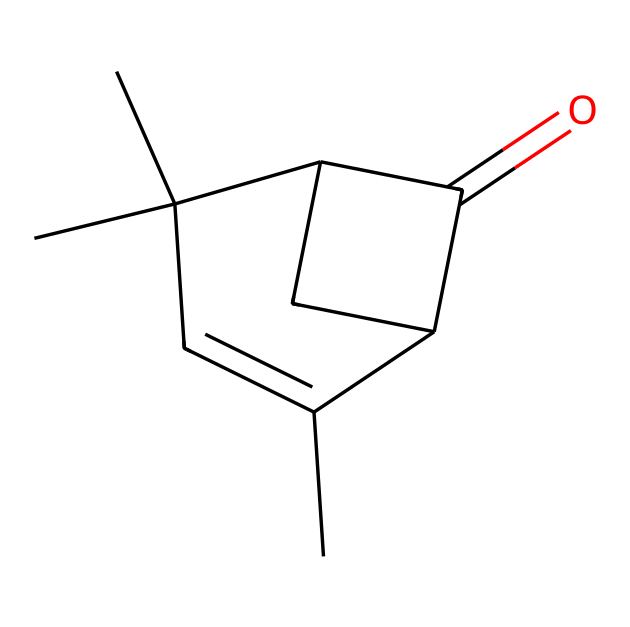What is the molecular formula of the compound represented by the SMILES? Analyzing the SMILES representation, we can count each type of atom present. From the structure, we see 10 carbon atoms (C), 14 hydrogen atoms (H), and 1 oxygen atom (O), leading to the molecular formula C10H14O.
Answer: C10H14O How many carbon atoms are present in this compound? By examining the SMILES, we can count the number of carbon atoms shown in the structure. There are 10 instances of the letter 'C' indicating 10 carbon atoms in total.
Answer: 10 Does this compound contain any double bonds? Looking closely at the SMILES structure, we notice the presence of "=" in the sequence indicating points where double bonds occur. There is one double bond between carbon and oxygen in the carbonyl functional group.
Answer: Yes What functional group is present in this structure? In the SMILES, the presence of the aldehyde feature is indicated by the carbon atom bonded to a carbonyl (C=O) and a hydrogen atom. This identifies the compound as an aldehyde due to the presence of the carbonyl group with hydrogen.
Answer: Aldehyde How many rings are present in this molecule? Observing the connections and the cyclic nature of the molecule in the SMILES, we notice two distinct cycles (rings) can be identified based on the structure where the carbon atoms form closed loops.
Answer: 2 Is this molecule likely to have a sweet smell, typical of many aldehydes? Considering that aldehydes often possess strong aromatic properties and some have pleasant fragrances, it is reasonable to assume this compound could exhibit a sweet odor typical of aldehydes due to its structure.
Answer: Yes What is the total number of hydrogen atoms? By going through the structure and counting each hydrogen (indicated implicitly in the SMILES by the structure and bonding patterns), we find that there are a total of 14 hydrogen atoms attached to the carbon atoms.
Answer: 14 